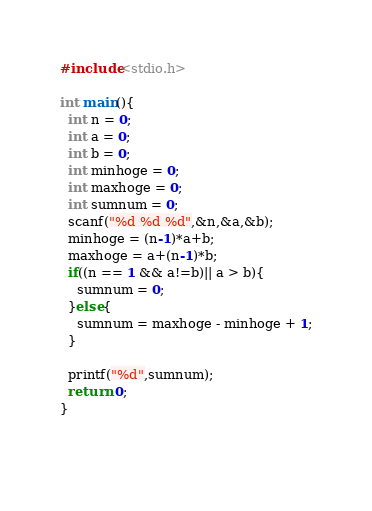Convert code to text. <code><loc_0><loc_0><loc_500><loc_500><_C_>#include<stdio.h>

int main(){
  int n = 0;
  int a = 0;
  int b = 0;
  int minhoge = 0;
  int maxhoge = 0;
  int sumnum = 0;
  scanf("%d %d %d",&n,&a,&b);
  minhoge = (n-1)*a+b;
  maxhoge = a+(n-1)*b;
  if((n == 1 && a!=b)|| a > b){
    sumnum = 0;
  }else{
    sumnum = maxhoge - minhoge + 1;
  }
  
  printf("%d",sumnum);
  return 0;
}
        
    </code> 